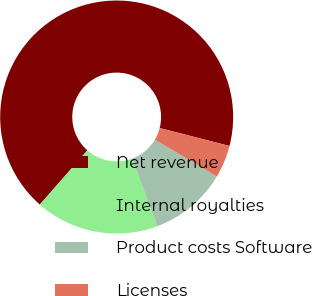<chart> <loc_0><loc_0><loc_500><loc_500><pie_chart><fcel>Net revenue<fcel>Internal royalties<fcel>Product costs Software<fcel>Licenses<nl><fcel>67.53%<fcel>17.12%<fcel>10.82%<fcel>4.52%<nl></chart> 